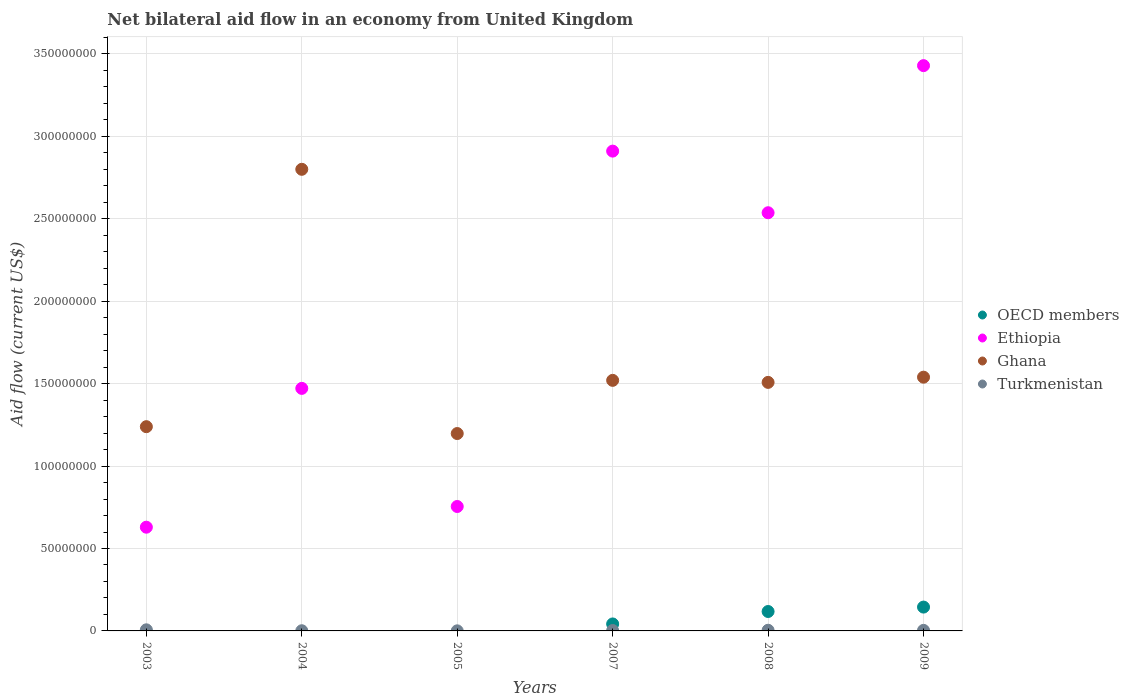Across all years, what is the maximum net bilateral aid flow in Ghana?
Provide a short and direct response. 2.80e+08. Across all years, what is the minimum net bilateral aid flow in OECD members?
Keep it short and to the point. 0. In which year was the net bilateral aid flow in Ethiopia maximum?
Make the answer very short. 2009. What is the total net bilateral aid flow in Ghana in the graph?
Give a very brief answer. 9.80e+08. What is the difference between the net bilateral aid flow in Ethiopia in 2003 and the net bilateral aid flow in OECD members in 2007?
Provide a succinct answer. 5.87e+07. What is the average net bilateral aid flow in OECD members per year?
Provide a succinct answer. 5.08e+06. In the year 2009, what is the difference between the net bilateral aid flow in OECD members and net bilateral aid flow in Turkmenistan?
Make the answer very short. 1.41e+07. What is the ratio of the net bilateral aid flow in Turkmenistan in 2005 to that in 2008?
Offer a very short reply. 0.12. What is the difference between the highest and the second highest net bilateral aid flow in Ghana?
Your response must be concise. 1.26e+08. What is the difference between the highest and the lowest net bilateral aid flow in Ethiopia?
Offer a terse response. 2.80e+08. In how many years, is the net bilateral aid flow in OECD members greater than the average net bilateral aid flow in OECD members taken over all years?
Make the answer very short. 2. Is it the case that in every year, the sum of the net bilateral aid flow in Ghana and net bilateral aid flow in OECD members  is greater than the net bilateral aid flow in Ethiopia?
Ensure brevity in your answer.  No. How many dotlines are there?
Your answer should be compact. 4. How many years are there in the graph?
Offer a very short reply. 6. Are the values on the major ticks of Y-axis written in scientific E-notation?
Provide a succinct answer. No. Does the graph contain any zero values?
Keep it short and to the point. Yes. How many legend labels are there?
Keep it short and to the point. 4. What is the title of the graph?
Your answer should be very brief. Net bilateral aid flow in an economy from United Kingdom. Does "Cambodia" appear as one of the legend labels in the graph?
Keep it short and to the point. No. What is the Aid flow (current US$) of OECD members in 2003?
Your answer should be compact. 0. What is the Aid flow (current US$) of Ethiopia in 2003?
Offer a terse response. 6.29e+07. What is the Aid flow (current US$) in Ghana in 2003?
Offer a terse response. 1.24e+08. What is the Aid flow (current US$) of Turkmenistan in 2003?
Give a very brief answer. 6.70e+05. What is the Aid flow (current US$) in OECD members in 2004?
Offer a very short reply. 0. What is the Aid flow (current US$) in Ethiopia in 2004?
Keep it short and to the point. 1.47e+08. What is the Aid flow (current US$) in Ghana in 2004?
Offer a very short reply. 2.80e+08. What is the Aid flow (current US$) in Ethiopia in 2005?
Offer a very short reply. 7.55e+07. What is the Aid flow (current US$) in Ghana in 2005?
Provide a short and direct response. 1.20e+08. What is the Aid flow (current US$) in Turkmenistan in 2005?
Ensure brevity in your answer.  5.00e+04. What is the Aid flow (current US$) of OECD members in 2007?
Provide a short and direct response. 4.23e+06. What is the Aid flow (current US$) in Ethiopia in 2007?
Make the answer very short. 2.91e+08. What is the Aid flow (current US$) in Ghana in 2007?
Make the answer very short. 1.52e+08. What is the Aid flow (current US$) of OECD members in 2008?
Your answer should be compact. 1.18e+07. What is the Aid flow (current US$) in Ethiopia in 2008?
Your answer should be compact. 2.54e+08. What is the Aid flow (current US$) in Ghana in 2008?
Offer a very short reply. 1.51e+08. What is the Aid flow (current US$) of OECD members in 2009?
Provide a succinct answer. 1.45e+07. What is the Aid flow (current US$) in Ethiopia in 2009?
Provide a succinct answer. 3.43e+08. What is the Aid flow (current US$) of Ghana in 2009?
Give a very brief answer. 1.54e+08. What is the Aid flow (current US$) of Turkmenistan in 2009?
Provide a short and direct response. 3.40e+05. Across all years, what is the maximum Aid flow (current US$) of OECD members?
Give a very brief answer. 1.45e+07. Across all years, what is the maximum Aid flow (current US$) in Ethiopia?
Your response must be concise. 3.43e+08. Across all years, what is the maximum Aid flow (current US$) in Ghana?
Offer a very short reply. 2.80e+08. Across all years, what is the maximum Aid flow (current US$) of Turkmenistan?
Keep it short and to the point. 6.70e+05. Across all years, what is the minimum Aid flow (current US$) of Ethiopia?
Keep it short and to the point. 6.29e+07. Across all years, what is the minimum Aid flow (current US$) in Ghana?
Provide a short and direct response. 1.20e+08. Across all years, what is the minimum Aid flow (current US$) of Turkmenistan?
Provide a succinct answer. 5.00e+04. What is the total Aid flow (current US$) of OECD members in the graph?
Keep it short and to the point. 3.05e+07. What is the total Aid flow (current US$) in Ethiopia in the graph?
Your answer should be compact. 1.17e+09. What is the total Aid flow (current US$) in Ghana in the graph?
Your response must be concise. 9.80e+08. What is the total Aid flow (current US$) of Turkmenistan in the graph?
Offer a very short reply. 1.81e+06. What is the difference between the Aid flow (current US$) of Ethiopia in 2003 and that in 2004?
Offer a very short reply. -8.42e+07. What is the difference between the Aid flow (current US$) of Ghana in 2003 and that in 2004?
Provide a short and direct response. -1.56e+08. What is the difference between the Aid flow (current US$) in Turkmenistan in 2003 and that in 2004?
Provide a succinct answer. 5.60e+05. What is the difference between the Aid flow (current US$) of Ethiopia in 2003 and that in 2005?
Provide a succinct answer. -1.26e+07. What is the difference between the Aid flow (current US$) in Ghana in 2003 and that in 2005?
Ensure brevity in your answer.  4.16e+06. What is the difference between the Aid flow (current US$) of Turkmenistan in 2003 and that in 2005?
Offer a terse response. 6.20e+05. What is the difference between the Aid flow (current US$) in Ethiopia in 2003 and that in 2007?
Provide a succinct answer. -2.28e+08. What is the difference between the Aid flow (current US$) of Ghana in 2003 and that in 2007?
Give a very brief answer. -2.81e+07. What is the difference between the Aid flow (current US$) of Ethiopia in 2003 and that in 2008?
Your answer should be very brief. -1.91e+08. What is the difference between the Aid flow (current US$) in Ghana in 2003 and that in 2008?
Your answer should be compact. -2.69e+07. What is the difference between the Aid flow (current US$) of Turkmenistan in 2003 and that in 2008?
Offer a terse response. 2.70e+05. What is the difference between the Aid flow (current US$) of Ethiopia in 2003 and that in 2009?
Provide a short and direct response. -2.80e+08. What is the difference between the Aid flow (current US$) in Ghana in 2003 and that in 2009?
Provide a short and direct response. -3.00e+07. What is the difference between the Aid flow (current US$) in Turkmenistan in 2003 and that in 2009?
Give a very brief answer. 3.30e+05. What is the difference between the Aid flow (current US$) in Ethiopia in 2004 and that in 2005?
Offer a very short reply. 7.16e+07. What is the difference between the Aid flow (current US$) of Ghana in 2004 and that in 2005?
Provide a succinct answer. 1.60e+08. What is the difference between the Aid flow (current US$) in Turkmenistan in 2004 and that in 2005?
Make the answer very short. 6.00e+04. What is the difference between the Aid flow (current US$) in Ethiopia in 2004 and that in 2007?
Give a very brief answer. -1.44e+08. What is the difference between the Aid flow (current US$) of Ghana in 2004 and that in 2007?
Provide a succinct answer. 1.28e+08. What is the difference between the Aid flow (current US$) of Ethiopia in 2004 and that in 2008?
Provide a short and direct response. -1.07e+08. What is the difference between the Aid flow (current US$) in Ghana in 2004 and that in 2008?
Ensure brevity in your answer.  1.29e+08. What is the difference between the Aid flow (current US$) in Ethiopia in 2004 and that in 2009?
Your answer should be very brief. -1.96e+08. What is the difference between the Aid flow (current US$) of Ghana in 2004 and that in 2009?
Ensure brevity in your answer.  1.26e+08. What is the difference between the Aid flow (current US$) in Turkmenistan in 2004 and that in 2009?
Make the answer very short. -2.30e+05. What is the difference between the Aid flow (current US$) in Ethiopia in 2005 and that in 2007?
Provide a succinct answer. -2.16e+08. What is the difference between the Aid flow (current US$) of Ghana in 2005 and that in 2007?
Keep it short and to the point. -3.23e+07. What is the difference between the Aid flow (current US$) of Ethiopia in 2005 and that in 2008?
Keep it short and to the point. -1.78e+08. What is the difference between the Aid flow (current US$) in Ghana in 2005 and that in 2008?
Your answer should be compact. -3.10e+07. What is the difference between the Aid flow (current US$) in Turkmenistan in 2005 and that in 2008?
Give a very brief answer. -3.50e+05. What is the difference between the Aid flow (current US$) in Ethiopia in 2005 and that in 2009?
Give a very brief answer. -2.67e+08. What is the difference between the Aid flow (current US$) of Ghana in 2005 and that in 2009?
Offer a very short reply. -3.42e+07. What is the difference between the Aid flow (current US$) of OECD members in 2007 and that in 2008?
Make the answer very short. -7.55e+06. What is the difference between the Aid flow (current US$) of Ethiopia in 2007 and that in 2008?
Give a very brief answer. 3.74e+07. What is the difference between the Aid flow (current US$) of Ghana in 2007 and that in 2008?
Provide a short and direct response. 1.23e+06. What is the difference between the Aid flow (current US$) of OECD members in 2007 and that in 2009?
Keep it short and to the point. -1.02e+07. What is the difference between the Aid flow (current US$) in Ethiopia in 2007 and that in 2009?
Your answer should be compact. -5.18e+07. What is the difference between the Aid flow (current US$) in Ghana in 2007 and that in 2009?
Offer a very short reply. -1.93e+06. What is the difference between the Aid flow (current US$) of OECD members in 2008 and that in 2009?
Your answer should be very brief. -2.68e+06. What is the difference between the Aid flow (current US$) in Ethiopia in 2008 and that in 2009?
Provide a short and direct response. -8.92e+07. What is the difference between the Aid flow (current US$) in Ghana in 2008 and that in 2009?
Provide a short and direct response. -3.16e+06. What is the difference between the Aid flow (current US$) of Ethiopia in 2003 and the Aid flow (current US$) of Ghana in 2004?
Keep it short and to the point. -2.17e+08. What is the difference between the Aid flow (current US$) of Ethiopia in 2003 and the Aid flow (current US$) of Turkmenistan in 2004?
Give a very brief answer. 6.28e+07. What is the difference between the Aid flow (current US$) in Ghana in 2003 and the Aid flow (current US$) in Turkmenistan in 2004?
Your answer should be very brief. 1.24e+08. What is the difference between the Aid flow (current US$) in Ethiopia in 2003 and the Aid flow (current US$) in Ghana in 2005?
Provide a short and direct response. -5.68e+07. What is the difference between the Aid flow (current US$) of Ethiopia in 2003 and the Aid flow (current US$) of Turkmenistan in 2005?
Provide a succinct answer. 6.29e+07. What is the difference between the Aid flow (current US$) of Ghana in 2003 and the Aid flow (current US$) of Turkmenistan in 2005?
Provide a succinct answer. 1.24e+08. What is the difference between the Aid flow (current US$) of Ethiopia in 2003 and the Aid flow (current US$) of Ghana in 2007?
Give a very brief answer. -8.91e+07. What is the difference between the Aid flow (current US$) in Ethiopia in 2003 and the Aid flow (current US$) in Turkmenistan in 2007?
Offer a very short reply. 6.27e+07. What is the difference between the Aid flow (current US$) of Ghana in 2003 and the Aid flow (current US$) of Turkmenistan in 2007?
Your answer should be very brief. 1.24e+08. What is the difference between the Aid flow (current US$) of Ethiopia in 2003 and the Aid flow (current US$) of Ghana in 2008?
Ensure brevity in your answer.  -8.78e+07. What is the difference between the Aid flow (current US$) in Ethiopia in 2003 and the Aid flow (current US$) in Turkmenistan in 2008?
Keep it short and to the point. 6.25e+07. What is the difference between the Aid flow (current US$) in Ghana in 2003 and the Aid flow (current US$) in Turkmenistan in 2008?
Keep it short and to the point. 1.24e+08. What is the difference between the Aid flow (current US$) in Ethiopia in 2003 and the Aid flow (current US$) in Ghana in 2009?
Your response must be concise. -9.10e+07. What is the difference between the Aid flow (current US$) in Ethiopia in 2003 and the Aid flow (current US$) in Turkmenistan in 2009?
Keep it short and to the point. 6.26e+07. What is the difference between the Aid flow (current US$) in Ghana in 2003 and the Aid flow (current US$) in Turkmenistan in 2009?
Your response must be concise. 1.24e+08. What is the difference between the Aid flow (current US$) of Ethiopia in 2004 and the Aid flow (current US$) of Ghana in 2005?
Your response must be concise. 2.74e+07. What is the difference between the Aid flow (current US$) of Ethiopia in 2004 and the Aid flow (current US$) of Turkmenistan in 2005?
Ensure brevity in your answer.  1.47e+08. What is the difference between the Aid flow (current US$) of Ghana in 2004 and the Aid flow (current US$) of Turkmenistan in 2005?
Your answer should be very brief. 2.80e+08. What is the difference between the Aid flow (current US$) in Ethiopia in 2004 and the Aid flow (current US$) in Ghana in 2007?
Your response must be concise. -4.87e+06. What is the difference between the Aid flow (current US$) of Ethiopia in 2004 and the Aid flow (current US$) of Turkmenistan in 2007?
Your answer should be compact. 1.47e+08. What is the difference between the Aid flow (current US$) of Ghana in 2004 and the Aid flow (current US$) of Turkmenistan in 2007?
Your answer should be compact. 2.80e+08. What is the difference between the Aid flow (current US$) in Ethiopia in 2004 and the Aid flow (current US$) in Ghana in 2008?
Give a very brief answer. -3.64e+06. What is the difference between the Aid flow (current US$) in Ethiopia in 2004 and the Aid flow (current US$) in Turkmenistan in 2008?
Your response must be concise. 1.47e+08. What is the difference between the Aid flow (current US$) in Ghana in 2004 and the Aid flow (current US$) in Turkmenistan in 2008?
Make the answer very short. 2.80e+08. What is the difference between the Aid flow (current US$) of Ethiopia in 2004 and the Aid flow (current US$) of Ghana in 2009?
Make the answer very short. -6.80e+06. What is the difference between the Aid flow (current US$) in Ethiopia in 2004 and the Aid flow (current US$) in Turkmenistan in 2009?
Your answer should be very brief. 1.47e+08. What is the difference between the Aid flow (current US$) in Ghana in 2004 and the Aid flow (current US$) in Turkmenistan in 2009?
Offer a very short reply. 2.80e+08. What is the difference between the Aid flow (current US$) of Ethiopia in 2005 and the Aid flow (current US$) of Ghana in 2007?
Provide a short and direct response. -7.65e+07. What is the difference between the Aid flow (current US$) of Ethiopia in 2005 and the Aid flow (current US$) of Turkmenistan in 2007?
Your answer should be compact. 7.52e+07. What is the difference between the Aid flow (current US$) of Ghana in 2005 and the Aid flow (current US$) of Turkmenistan in 2007?
Provide a succinct answer. 1.20e+08. What is the difference between the Aid flow (current US$) in Ethiopia in 2005 and the Aid flow (current US$) in Ghana in 2008?
Your answer should be very brief. -7.53e+07. What is the difference between the Aid flow (current US$) of Ethiopia in 2005 and the Aid flow (current US$) of Turkmenistan in 2008?
Your response must be concise. 7.51e+07. What is the difference between the Aid flow (current US$) of Ghana in 2005 and the Aid flow (current US$) of Turkmenistan in 2008?
Your response must be concise. 1.19e+08. What is the difference between the Aid flow (current US$) of Ethiopia in 2005 and the Aid flow (current US$) of Ghana in 2009?
Offer a very short reply. -7.84e+07. What is the difference between the Aid flow (current US$) of Ethiopia in 2005 and the Aid flow (current US$) of Turkmenistan in 2009?
Ensure brevity in your answer.  7.51e+07. What is the difference between the Aid flow (current US$) of Ghana in 2005 and the Aid flow (current US$) of Turkmenistan in 2009?
Offer a terse response. 1.19e+08. What is the difference between the Aid flow (current US$) of OECD members in 2007 and the Aid flow (current US$) of Ethiopia in 2008?
Your answer should be very brief. -2.49e+08. What is the difference between the Aid flow (current US$) in OECD members in 2007 and the Aid flow (current US$) in Ghana in 2008?
Ensure brevity in your answer.  -1.47e+08. What is the difference between the Aid flow (current US$) of OECD members in 2007 and the Aid flow (current US$) of Turkmenistan in 2008?
Offer a very short reply. 3.83e+06. What is the difference between the Aid flow (current US$) in Ethiopia in 2007 and the Aid flow (current US$) in Ghana in 2008?
Offer a very short reply. 1.40e+08. What is the difference between the Aid flow (current US$) in Ethiopia in 2007 and the Aid flow (current US$) in Turkmenistan in 2008?
Your response must be concise. 2.91e+08. What is the difference between the Aid flow (current US$) in Ghana in 2007 and the Aid flow (current US$) in Turkmenistan in 2008?
Offer a terse response. 1.52e+08. What is the difference between the Aid flow (current US$) in OECD members in 2007 and the Aid flow (current US$) in Ethiopia in 2009?
Keep it short and to the point. -3.39e+08. What is the difference between the Aid flow (current US$) of OECD members in 2007 and the Aid flow (current US$) of Ghana in 2009?
Offer a terse response. -1.50e+08. What is the difference between the Aid flow (current US$) of OECD members in 2007 and the Aid flow (current US$) of Turkmenistan in 2009?
Give a very brief answer. 3.89e+06. What is the difference between the Aid flow (current US$) of Ethiopia in 2007 and the Aid flow (current US$) of Ghana in 2009?
Ensure brevity in your answer.  1.37e+08. What is the difference between the Aid flow (current US$) in Ethiopia in 2007 and the Aid flow (current US$) in Turkmenistan in 2009?
Keep it short and to the point. 2.91e+08. What is the difference between the Aid flow (current US$) of Ghana in 2007 and the Aid flow (current US$) of Turkmenistan in 2009?
Your response must be concise. 1.52e+08. What is the difference between the Aid flow (current US$) in OECD members in 2008 and the Aid flow (current US$) in Ethiopia in 2009?
Your answer should be compact. -3.31e+08. What is the difference between the Aid flow (current US$) of OECD members in 2008 and the Aid flow (current US$) of Ghana in 2009?
Offer a very short reply. -1.42e+08. What is the difference between the Aid flow (current US$) in OECD members in 2008 and the Aid flow (current US$) in Turkmenistan in 2009?
Provide a short and direct response. 1.14e+07. What is the difference between the Aid flow (current US$) in Ethiopia in 2008 and the Aid flow (current US$) in Ghana in 2009?
Your answer should be very brief. 9.98e+07. What is the difference between the Aid flow (current US$) of Ethiopia in 2008 and the Aid flow (current US$) of Turkmenistan in 2009?
Provide a succinct answer. 2.53e+08. What is the difference between the Aid flow (current US$) of Ghana in 2008 and the Aid flow (current US$) of Turkmenistan in 2009?
Give a very brief answer. 1.50e+08. What is the average Aid flow (current US$) in OECD members per year?
Your response must be concise. 5.08e+06. What is the average Aid flow (current US$) in Ethiopia per year?
Ensure brevity in your answer.  1.96e+08. What is the average Aid flow (current US$) of Ghana per year?
Provide a short and direct response. 1.63e+08. What is the average Aid flow (current US$) in Turkmenistan per year?
Keep it short and to the point. 3.02e+05. In the year 2003, what is the difference between the Aid flow (current US$) in Ethiopia and Aid flow (current US$) in Ghana?
Provide a short and direct response. -6.10e+07. In the year 2003, what is the difference between the Aid flow (current US$) in Ethiopia and Aid flow (current US$) in Turkmenistan?
Your answer should be very brief. 6.22e+07. In the year 2003, what is the difference between the Aid flow (current US$) in Ghana and Aid flow (current US$) in Turkmenistan?
Provide a short and direct response. 1.23e+08. In the year 2004, what is the difference between the Aid flow (current US$) in Ethiopia and Aid flow (current US$) in Ghana?
Your answer should be very brief. -1.33e+08. In the year 2004, what is the difference between the Aid flow (current US$) in Ethiopia and Aid flow (current US$) in Turkmenistan?
Provide a succinct answer. 1.47e+08. In the year 2004, what is the difference between the Aid flow (current US$) of Ghana and Aid flow (current US$) of Turkmenistan?
Provide a succinct answer. 2.80e+08. In the year 2005, what is the difference between the Aid flow (current US$) of Ethiopia and Aid flow (current US$) of Ghana?
Offer a terse response. -4.43e+07. In the year 2005, what is the difference between the Aid flow (current US$) in Ethiopia and Aid flow (current US$) in Turkmenistan?
Make the answer very short. 7.54e+07. In the year 2005, what is the difference between the Aid flow (current US$) of Ghana and Aid flow (current US$) of Turkmenistan?
Ensure brevity in your answer.  1.20e+08. In the year 2007, what is the difference between the Aid flow (current US$) of OECD members and Aid flow (current US$) of Ethiopia?
Your answer should be compact. -2.87e+08. In the year 2007, what is the difference between the Aid flow (current US$) in OECD members and Aid flow (current US$) in Ghana?
Give a very brief answer. -1.48e+08. In the year 2007, what is the difference between the Aid flow (current US$) in OECD members and Aid flow (current US$) in Turkmenistan?
Your answer should be very brief. 3.99e+06. In the year 2007, what is the difference between the Aid flow (current US$) in Ethiopia and Aid flow (current US$) in Ghana?
Your answer should be very brief. 1.39e+08. In the year 2007, what is the difference between the Aid flow (current US$) in Ethiopia and Aid flow (current US$) in Turkmenistan?
Offer a terse response. 2.91e+08. In the year 2007, what is the difference between the Aid flow (current US$) in Ghana and Aid flow (current US$) in Turkmenistan?
Your response must be concise. 1.52e+08. In the year 2008, what is the difference between the Aid flow (current US$) in OECD members and Aid flow (current US$) in Ethiopia?
Give a very brief answer. -2.42e+08. In the year 2008, what is the difference between the Aid flow (current US$) in OECD members and Aid flow (current US$) in Ghana?
Ensure brevity in your answer.  -1.39e+08. In the year 2008, what is the difference between the Aid flow (current US$) in OECD members and Aid flow (current US$) in Turkmenistan?
Provide a short and direct response. 1.14e+07. In the year 2008, what is the difference between the Aid flow (current US$) of Ethiopia and Aid flow (current US$) of Ghana?
Provide a short and direct response. 1.03e+08. In the year 2008, what is the difference between the Aid flow (current US$) in Ethiopia and Aid flow (current US$) in Turkmenistan?
Keep it short and to the point. 2.53e+08. In the year 2008, what is the difference between the Aid flow (current US$) in Ghana and Aid flow (current US$) in Turkmenistan?
Offer a very short reply. 1.50e+08. In the year 2009, what is the difference between the Aid flow (current US$) of OECD members and Aid flow (current US$) of Ethiopia?
Give a very brief answer. -3.28e+08. In the year 2009, what is the difference between the Aid flow (current US$) in OECD members and Aid flow (current US$) in Ghana?
Your answer should be very brief. -1.39e+08. In the year 2009, what is the difference between the Aid flow (current US$) of OECD members and Aid flow (current US$) of Turkmenistan?
Keep it short and to the point. 1.41e+07. In the year 2009, what is the difference between the Aid flow (current US$) of Ethiopia and Aid flow (current US$) of Ghana?
Ensure brevity in your answer.  1.89e+08. In the year 2009, what is the difference between the Aid flow (current US$) of Ethiopia and Aid flow (current US$) of Turkmenistan?
Keep it short and to the point. 3.43e+08. In the year 2009, what is the difference between the Aid flow (current US$) of Ghana and Aid flow (current US$) of Turkmenistan?
Offer a terse response. 1.54e+08. What is the ratio of the Aid flow (current US$) of Ethiopia in 2003 to that in 2004?
Ensure brevity in your answer.  0.43. What is the ratio of the Aid flow (current US$) in Ghana in 2003 to that in 2004?
Your answer should be compact. 0.44. What is the ratio of the Aid flow (current US$) in Turkmenistan in 2003 to that in 2004?
Your response must be concise. 6.09. What is the ratio of the Aid flow (current US$) in Ethiopia in 2003 to that in 2005?
Ensure brevity in your answer.  0.83. What is the ratio of the Aid flow (current US$) of Ghana in 2003 to that in 2005?
Make the answer very short. 1.03. What is the ratio of the Aid flow (current US$) of Turkmenistan in 2003 to that in 2005?
Your response must be concise. 13.4. What is the ratio of the Aid flow (current US$) in Ethiopia in 2003 to that in 2007?
Ensure brevity in your answer.  0.22. What is the ratio of the Aid flow (current US$) of Ghana in 2003 to that in 2007?
Your answer should be very brief. 0.82. What is the ratio of the Aid flow (current US$) in Turkmenistan in 2003 to that in 2007?
Give a very brief answer. 2.79. What is the ratio of the Aid flow (current US$) in Ethiopia in 2003 to that in 2008?
Provide a short and direct response. 0.25. What is the ratio of the Aid flow (current US$) of Ghana in 2003 to that in 2008?
Ensure brevity in your answer.  0.82. What is the ratio of the Aid flow (current US$) in Turkmenistan in 2003 to that in 2008?
Your answer should be compact. 1.68. What is the ratio of the Aid flow (current US$) of Ethiopia in 2003 to that in 2009?
Your response must be concise. 0.18. What is the ratio of the Aid flow (current US$) of Ghana in 2003 to that in 2009?
Your answer should be compact. 0.8. What is the ratio of the Aid flow (current US$) of Turkmenistan in 2003 to that in 2009?
Provide a succinct answer. 1.97. What is the ratio of the Aid flow (current US$) in Ethiopia in 2004 to that in 2005?
Provide a short and direct response. 1.95. What is the ratio of the Aid flow (current US$) in Ghana in 2004 to that in 2005?
Keep it short and to the point. 2.34. What is the ratio of the Aid flow (current US$) in Turkmenistan in 2004 to that in 2005?
Offer a very short reply. 2.2. What is the ratio of the Aid flow (current US$) in Ethiopia in 2004 to that in 2007?
Provide a short and direct response. 0.51. What is the ratio of the Aid flow (current US$) of Ghana in 2004 to that in 2007?
Provide a succinct answer. 1.84. What is the ratio of the Aid flow (current US$) in Turkmenistan in 2004 to that in 2007?
Your answer should be compact. 0.46. What is the ratio of the Aid flow (current US$) of Ethiopia in 2004 to that in 2008?
Ensure brevity in your answer.  0.58. What is the ratio of the Aid flow (current US$) of Ghana in 2004 to that in 2008?
Offer a terse response. 1.86. What is the ratio of the Aid flow (current US$) of Turkmenistan in 2004 to that in 2008?
Your response must be concise. 0.28. What is the ratio of the Aid flow (current US$) in Ethiopia in 2004 to that in 2009?
Provide a succinct answer. 0.43. What is the ratio of the Aid flow (current US$) of Ghana in 2004 to that in 2009?
Provide a succinct answer. 1.82. What is the ratio of the Aid flow (current US$) in Turkmenistan in 2004 to that in 2009?
Provide a succinct answer. 0.32. What is the ratio of the Aid flow (current US$) in Ethiopia in 2005 to that in 2007?
Make the answer very short. 0.26. What is the ratio of the Aid flow (current US$) of Ghana in 2005 to that in 2007?
Provide a short and direct response. 0.79. What is the ratio of the Aid flow (current US$) of Turkmenistan in 2005 to that in 2007?
Make the answer very short. 0.21. What is the ratio of the Aid flow (current US$) of Ethiopia in 2005 to that in 2008?
Your response must be concise. 0.3. What is the ratio of the Aid flow (current US$) of Ghana in 2005 to that in 2008?
Offer a terse response. 0.79. What is the ratio of the Aid flow (current US$) in Ethiopia in 2005 to that in 2009?
Make the answer very short. 0.22. What is the ratio of the Aid flow (current US$) of Ghana in 2005 to that in 2009?
Offer a very short reply. 0.78. What is the ratio of the Aid flow (current US$) in Turkmenistan in 2005 to that in 2009?
Keep it short and to the point. 0.15. What is the ratio of the Aid flow (current US$) in OECD members in 2007 to that in 2008?
Give a very brief answer. 0.36. What is the ratio of the Aid flow (current US$) in Ethiopia in 2007 to that in 2008?
Ensure brevity in your answer.  1.15. What is the ratio of the Aid flow (current US$) of Ghana in 2007 to that in 2008?
Provide a succinct answer. 1.01. What is the ratio of the Aid flow (current US$) in Turkmenistan in 2007 to that in 2008?
Offer a very short reply. 0.6. What is the ratio of the Aid flow (current US$) in OECD members in 2007 to that in 2009?
Make the answer very short. 0.29. What is the ratio of the Aid flow (current US$) of Ethiopia in 2007 to that in 2009?
Ensure brevity in your answer.  0.85. What is the ratio of the Aid flow (current US$) in Ghana in 2007 to that in 2009?
Provide a succinct answer. 0.99. What is the ratio of the Aid flow (current US$) in Turkmenistan in 2007 to that in 2009?
Provide a succinct answer. 0.71. What is the ratio of the Aid flow (current US$) of OECD members in 2008 to that in 2009?
Make the answer very short. 0.81. What is the ratio of the Aid flow (current US$) of Ethiopia in 2008 to that in 2009?
Give a very brief answer. 0.74. What is the ratio of the Aid flow (current US$) in Ghana in 2008 to that in 2009?
Ensure brevity in your answer.  0.98. What is the ratio of the Aid flow (current US$) in Turkmenistan in 2008 to that in 2009?
Offer a very short reply. 1.18. What is the difference between the highest and the second highest Aid flow (current US$) in OECD members?
Make the answer very short. 2.68e+06. What is the difference between the highest and the second highest Aid flow (current US$) of Ethiopia?
Offer a very short reply. 5.18e+07. What is the difference between the highest and the second highest Aid flow (current US$) of Ghana?
Your response must be concise. 1.26e+08. What is the difference between the highest and the lowest Aid flow (current US$) of OECD members?
Provide a succinct answer. 1.45e+07. What is the difference between the highest and the lowest Aid flow (current US$) in Ethiopia?
Provide a short and direct response. 2.80e+08. What is the difference between the highest and the lowest Aid flow (current US$) in Ghana?
Make the answer very short. 1.60e+08. What is the difference between the highest and the lowest Aid flow (current US$) in Turkmenistan?
Keep it short and to the point. 6.20e+05. 